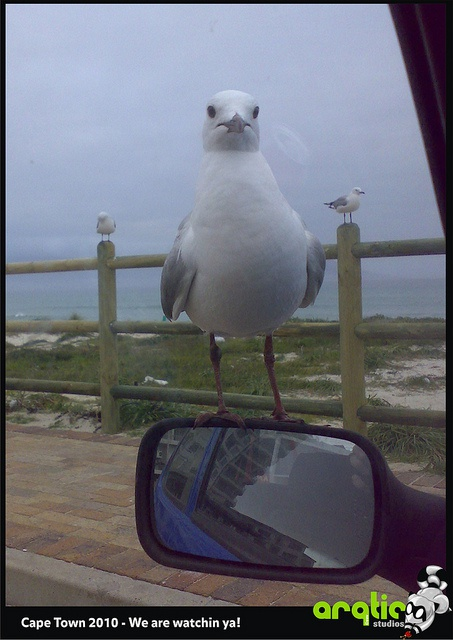Describe the objects in this image and their specific colors. I can see car in black and gray tones, bird in black, gray, and darkgray tones, bird in black, darkgray, and gray tones, and bird in black, gray, and darkgray tones in this image. 